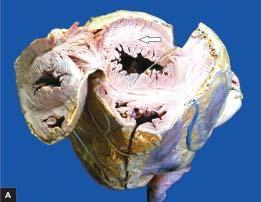what is increased?
Answer the question using a single word or phrase. Weight of the heart 